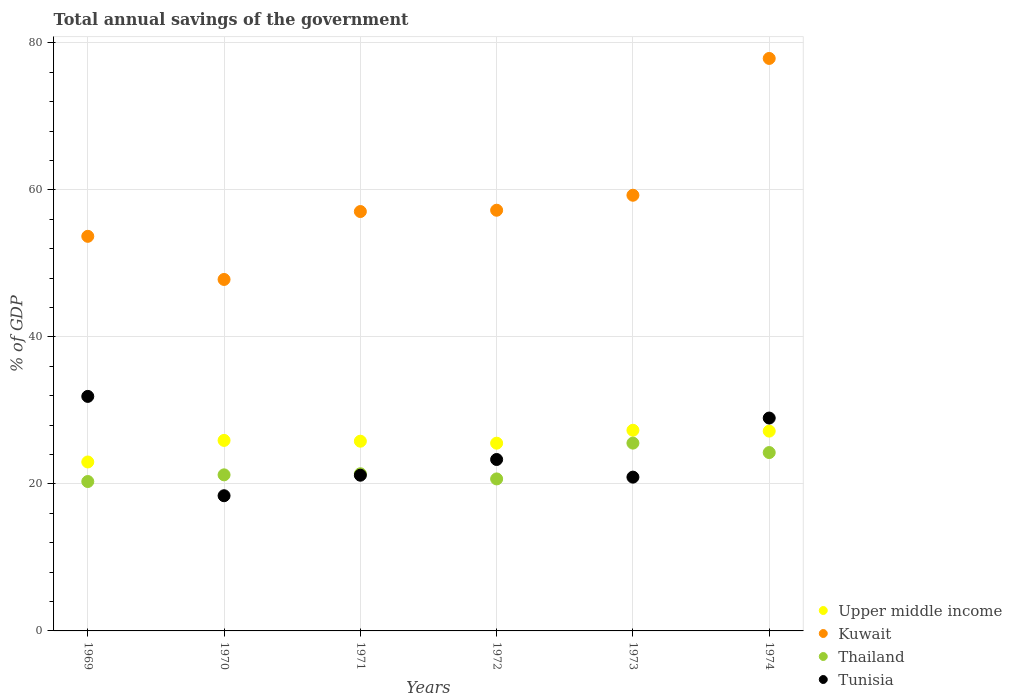Is the number of dotlines equal to the number of legend labels?
Your answer should be very brief. Yes. What is the total annual savings of the government in Kuwait in 1970?
Give a very brief answer. 47.82. Across all years, what is the maximum total annual savings of the government in Tunisia?
Your response must be concise. 31.91. Across all years, what is the minimum total annual savings of the government in Thailand?
Offer a terse response. 20.33. In which year was the total annual savings of the government in Tunisia maximum?
Keep it short and to the point. 1969. In which year was the total annual savings of the government in Kuwait minimum?
Your response must be concise. 1970. What is the total total annual savings of the government in Upper middle income in the graph?
Your response must be concise. 154.76. What is the difference between the total annual savings of the government in Kuwait in 1972 and that in 1973?
Keep it short and to the point. -2.04. What is the difference between the total annual savings of the government in Upper middle income in 1973 and the total annual savings of the government in Thailand in 1972?
Ensure brevity in your answer.  6.62. What is the average total annual savings of the government in Thailand per year?
Your answer should be compact. 22.24. In the year 1971, what is the difference between the total annual savings of the government in Tunisia and total annual savings of the government in Upper middle income?
Provide a short and direct response. -4.63. What is the ratio of the total annual savings of the government in Upper middle income in 1970 to that in 1974?
Your response must be concise. 0.95. Is the total annual savings of the government in Thailand in 1969 less than that in 1970?
Offer a terse response. Yes. What is the difference between the highest and the second highest total annual savings of the government in Upper middle income?
Provide a succinct answer. 0.12. What is the difference between the highest and the lowest total annual savings of the government in Tunisia?
Offer a very short reply. 13.51. In how many years, is the total annual savings of the government in Thailand greater than the average total annual savings of the government in Thailand taken over all years?
Your answer should be compact. 2. Is the sum of the total annual savings of the government in Thailand in 1969 and 1974 greater than the maximum total annual savings of the government in Upper middle income across all years?
Offer a terse response. Yes. Is it the case that in every year, the sum of the total annual savings of the government in Kuwait and total annual savings of the government in Upper middle income  is greater than the total annual savings of the government in Tunisia?
Provide a succinct answer. Yes. Is the total annual savings of the government in Kuwait strictly greater than the total annual savings of the government in Tunisia over the years?
Your answer should be compact. Yes. Is the total annual savings of the government in Thailand strictly less than the total annual savings of the government in Tunisia over the years?
Offer a terse response. No. How many years are there in the graph?
Offer a very short reply. 6. What is the difference between two consecutive major ticks on the Y-axis?
Give a very brief answer. 20. Are the values on the major ticks of Y-axis written in scientific E-notation?
Ensure brevity in your answer.  No. Does the graph contain any zero values?
Provide a succinct answer. No. Where does the legend appear in the graph?
Provide a short and direct response. Bottom right. How many legend labels are there?
Ensure brevity in your answer.  4. What is the title of the graph?
Your answer should be very brief. Total annual savings of the government. Does "Chad" appear as one of the legend labels in the graph?
Provide a short and direct response. No. What is the label or title of the X-axis?
Keep it short and to the point. Years. What is the label or title of the Y-axis?
Your answer should be compact. % of GDP. What is the % of GDP in Upper middle income in 1969?
Offer a terse response. 22.99. What is the % of GDP in Kuwait in 1969?
Make the answer very short. 53.69. What is the % of GDP in Thailand in 1969?
Your response must be concise. 20.33. What is the % of GDP in Tunisia in 1969?
Give a very brief answer. 31.91. What is the % of GDP of Upper middle income in 1970?
Your answer should be compact. 25.92. What is the % of GDP of Kuwait in 1970?
Make the answer very short. 47.82. What is the % of GDP of Thailand in 1970?
Offer a very short reply. 21.24. What is the % of GDP in Tunisia in 1970?
Offer a very short reply. 18.4. What is the % of GDP in Upper middle income in 1971?
Offer a very short reply. 25.81. What is the % of GDP of Kuwait in 1971?
Make the answer very short. 57.06. What is the % of GDP of Thailand in 1971?
Your answer should be very brief. 21.38. What is the % of GDP in Tunisia in 1971?
Provide a short and direct response. 21.19. What is the % of GDP of Upper middle income in 1972?
Offer a terse response. 25.54. What is the % of GDP of Kuwait in 1972?
Give a very brief answer. 57.24. What is the % of GDP of Thailand in 1972?
Make the answer very short. 20.68. What is the % of GDP in Tunisia in 1972?
Your response must be concise. 23.33. What is the % of GDP in Upper middle income in 1973?
Ensure brevity in your answer.  27.3. What is the % of GDP of Kuwait in 1973?
Provide a succinct answer. 59.28. What is the % of GDP in Thailand in 1973?
Your answer should be very brief. 25.55. What is the % of GDP in Tunisia in 1973?
Ensure brevity in your answer.  20.92. What is the % of GDP in Upper middle income in 1974?
Provide a short and direct response. 27.19. What is the % of GDP of Kuwait in 1974?
Give a very brief answer. 77.89. What is the % of GDP of Thailand in 1974?
Provide a succinct answer. 24.27. What is the % of GDP of Tunisia in 1974?
Provide a short and direct response. 28.96. Across all years, what is the maximum % of GDP of Upper middle income?
Provide a short and direct response. 27.3. Across all years, what is the maximum % of GDP in Kuwait?
Your answer should be compact. 77.89. Across all years, what is the maximum % of GDP in Thailand?
Your answer should be compact. 25.55. Across all years, what is the maximum % of GDP in Tunisia?
Ensure brevity in your answer.  31.91. Across all years, what is the minimum % of GDP of Upper middle income?
Provide a succinct answer. 22.99. Across all years, what is the minimum % of GDP in Kuwait?
Give a very brief answer. 47.82. Across all years, what is the minimum % of GDP in Thailand?
Provide a succinct answer. 20.33. Across all years, what is the minimum % of GDP in Tunisia?
Your answer should be very brief. 18.4. What is the total % of GDP of Upper middle income in the graph?
Provide a short and direct response. 154.76. What is the total % of GDP in Kuwait in the graph?
Provide a succinct answer. 352.99. What is the total % of GDP in Thailand in the graph?
Offer a terse response. 133.45. What is the total % of GDP in Tunisia in the graph?
Your answer should be very brief. 144.71. What is the difference between the % of GDP of Upper middle income in 1969 and that in 1970?
Your response must be concise. -2.93. What is the difference between the % of GDP of Kuwait in 1969 and that in 1970?
Your answer should be compact. 5.87. What is the difference between the % of GDP of Thailand in 1969 and that in 1970?
Your answer should be very brief. -0.91. What is the difference between the % of GDP of Tunisia in 1969 and that in 1970?
Ensure brevity in your answer.  13.51. What is the difference between the % of GDP in Upper middle income in 1969 and that in 1971?
Your answer should be very brief. -2.83. What is the difference between the % of GDP in Kuwait in 1969 and that in 1971?
Keep it short and to the point. -3.37. What is the difference between the % of GDP of Thailand in 1969 and that in 1971?
Provide a succinct answer. -1.06. What is the difference between the % of GDP in Tunisia in 1969 and that in 1971?
Ensure brevity in your answer.  10.72. What is the difference between the % of GDP of Upper middle income in 1969 and that in 1972?
Your answer should be very brief. -2.56. What is the difference between the % of GDP of Kuwait in 1969 and that in 1972?
Give a very brief answer. -3.55. What is the difference between the % of GDP of Thailand in 1969 and that in 1972?
Make the answer very short. -0.35. What is the difference between the % of GDP in Tunisia in 1969 and that in 1972?
Make the answer very short. 8.59. What is the difference between the % of GDP in Upper middle income in 1969 and that in 1973?
Your answer should be compact. -4.31. What is the difference between the % of GDP in Kuwait in 1969 and that in 1973?
Keep it short and to the point. -5.59. What is the difference between the % of GDP in Thailand in 1969 and that in 1973?
Offer a very short reply. -5.23. What is the difference between the % of GDP in Tunisia in 1969 and that in 1973?
Give a very brief answer. 10.99. What is the difference between the % of GDP in Upper middle income in 1969 and that in 1974?
Ensure brevity in your answer.  -4.2. What is the difference between the % of GDP in Kuwait in 1969 and that in 1974?
Offer a terse response. -24.2. What is the difference between the % of GDP of Thailand in 1969 and that in 1974?
Offer a terse response. -3.94. What is the difference between the % of GDP in Tunisia in 1969 and that in 1974?
Ensure brevity in your answer.  2.95. What is the difference between the % of GDP in Upper middle income in 1970 and that in 1971?
Provide a succinct answer. 0.11. What is the difference between the % of GDP of Kuwait in 1970 and that in 1971?
Your answer should be compact. -9.24. What is the difference between the % of GDP of Thailand in 1970 and that in 1971?
Give a very brief answer. -0.15. What is the difference between the % of GDP in Tunisia in 1970 and that in 1971?
Keep it short and to the point. -2.79. What is the difference between the % of GDP in Upper middle income in 1970 and that in 1972?
Offer a terse response. 0.38. What is the difference between the % of GDP of Kuwait in 1970 and that in 1972?
Provide a succinct answer. -9.42. What is the difference between the % of GDP of Thailand in 1970 and that in 1972?
Offer a very short reply. 0.55. What is the difference between the % of GDP of Tunisia in 1970 and that in 1972?
Provide a succinct answer. -4.93. What is the difference between the % of GDP in Upper middle income in 1970 and that in 1973?
Your answer should be compact. -1.38. What is the difference between the % of GDP of Kuwait in 1970 and that in 1973?
Ensure brevity in your answer.  -11.46. What is the difference between the % of GDP in Thailand in 1970 and that in 1973?
Offer a terse response. -4.32. What is the difference between the % of GDP in Tunisia in 1970 and that in 1973?
Offer a terse response. -2.53. What is the difference between the % of GDP in Upper middle income in 1970 and that in 1974?
Provide a succinct answer. -1.26. What is the difference between the % of GDP in Kuwait in 1970 and that in 1974?
Offer a terse response. -30.07. What is the difference between the % of GDP in Thailand in 1970 and that in 1974?
Provide a short and direct response. -3.03. What is the difference between the % of GDP of Tunisia in 1970 and that in 1974?
Your answer should be compact. -10.57. What is the difference between the % of GDP in Upper middle income in 1971 and that in 1972?
Offer a very short reply. 0.27. What is the difference between the % of GDP of Kuwait in 1971 and that in 1972?
Give a very brief answer. -0.18. What is the difference between the % of GDP in Thailand in 1971 and that in 1972?
Ensure brevity in your answer.  0.7. What is the difference between the % of GDP of Tunisia in 1971 and that in 1972?
Provide a succinct answer. -2.14. What is the difference between the % of GDP of Upper middle income in 1971 and that in 1973?
Give a very brief answer. -1.49. What is the difference between the % of GDP of Kuwait in 1971 and that in 1973?
Your response must be concise. -2.22. What is the difference between the % of GDP in Thailand in 1971 and that in 1973?
Provide a short and direct response. -4.17. What is the difference between the % of GDP in Tunisia in 1971 and that in 1973?
Provide a short and direct response. 0.26. What is the difference between the % of GDP of Upper middle income in 1971 and that in 1974?
Keep it short and to the point. -1.37. What is the difference between the % of GDP in Kuwait in 1971 and that in 1974?
Provide a short and direct response. -20.83. What is the difference between the % of GDP of Thailand in 1971 and that in 1974?
Your answer should be compact. -2.88. What is the difference between the % of GDP in Tunisia in 1971 and that in 1974?
Ensure brevity in your answer.  -7.78. What is the difference between the % of GDP of Upper middle income in 1972 and that in 1973?
Keep it short and to the point. -1.76. What is the difference between the % of GDP of Kuwait in 1972 and that in 1973?
Offer a terse response. -2.04. What is the difference between the % of GDP of Thailand in 1972 and that in 1973?
Ensure brevity in your answer.  -4.87. What is the difference between the % of GDP of Tunisia in 1972 and that in 1973?
Your answer should be compact. 2.4. What is the difference between the % of GDP in Upper middle income in 1972 and that in 1974?
Give a very brief answer. -1.64. What is the difference between the % of GDP in Kuwait in 1972 and that in 1974?
Your answer should be very brief. -20.65. What is the difference between the % of GDP in Thailand in 1972 and that in 1974?
Keep it short and to the point. -3.59. What is the difference between the % of GDP of Tunisia in 1972 and that in 1974?
Make the answer very short. -5.64. What is the difference between the % of GDP in Upper middle income in 1973 and that in 1974?
Provide a succinct answer. 0.12. What is the difference between the % of GDP of Kuwait in 1973 and that in 1974?
Make the answer very short. -18.61. What is the difference between the % of GDP in Thailand in 1973 and that in 1974?
Provide a short and direct response. 1.28. What is the difference between the % of GDP in Tunisia in 1973 and that in 1974?
Give a very brief answer. -8.04. What is the difference between the % of GDP of Upper middle income in 1969 and the % of GDP of Kuwait in 1970?
Provide a short and direct response. -24.83. What is the difference between the % of GDP of Upper middle income in 1969 and the % of GDP of Thailand in 1970?
Offer a very short reply. 1.75. What is the difference between the % of GDP of Upper middle income in 1969 and the % of GDP of Tunisia in 1970?
Ensure brevity in your answer.  4.59. What is the difference between the % of GDP of Kuwait in 1969 and the % of GDP of Thailand in 1970?
Provide a short and direct response. 32.45. What is the difference between the % of GDP in Kuwait in 1969 and the % of GDP in Tunisia in 1970?
Keep it short and to the point. 35.29. What is the difference between the % of GDP in Thailand in 1969 and the % of GDP in Tunisia in 1970?
Provide a short and direct response. 1.93. What is the difference between the % of GDP in Upper middle income in 1969 and the % of GDP in Kuwait in 1971?
Your answer should be compact. -34.08. What is the difference between the % of GDP in Upper middle income in 1969 and the % of GDP in Thailand in 1971?
Offer a terse response. 1.6. What is the difference between the % of GDP of Upper middle income in 1969 and the % of GDP of Tunisia in 1971?
Your answer should be compact. 1.8. What is the difference between the % of GDP in Kuwait in 1969 and the % of GDP in Thailand in 1971?
Give a very brief answer. 32.31. What is the difference between the % of GDP in Kuwait in 1969 and the % of GDP in Tunisia in 1971?
Your answer should be compact. 32.5. What is the difference between the % of GDP of Thailand in 1969 and the % of GDP of Tunisia in 1971?
Provide a succinct answer. -0.86. What is the difference between the % of GDP of Upper middle income in 1969 and the % of GDP of Kuwait in 1972?
Provide a short and direct response. -34.25. What is the difference between the % of GDP of Upper middle income in 1969 and the % of GDP of Thailand in 1972?
Provide a succinct answer. 2.31. What is the difference between the % of GDP in Upper middle income in 1969 and the % of GDP in Tunisia in 1972?
Provide a succinct answer. -0.34. What is the difference between the % of GDP of Kuwait in 1969 and the % of GDP of Thailand in 1972?
Offer a terse response. 33.01. What is the difference between the % of GDP of Kuwait in 1969 and the % of GDP of Tunisia in 1972?
Offer a terse response. 30.37. What is the difference between the % of GDP in Thailand in 1969 and the % of GDP in Tunisia in 1972?
Keep it short and to the point. -3. What is the difference between the % of GDP in Upper middle income in 1969 and the % of GDP in Kuwait in 1973?
Make the answer very short. -36.29. What is the difference between the % of GDP in Upper middle income in 1969 and the % of GDP in Thailand in 1973?
Keep it short and to the point. -2.56. What is the difference between the % of GDP in Upper middle income in 1969 and the % of GDP in Tunisia in 1973?
Ensure brevity in your answer.  2.06. What is the difference between the % of GDP in Kuwait in 1969 and the % of GDP in Thailand in 1973?
Provide a short and direct response. 28.14. What is the difference between the % of GDP in Kuwait in 1969 and the % of GDP in Tunisia in 1973?
Ensure brevity in your answer.  32.77. What is the difference between the % of GDP of Thailand in 1969 and the % of GDP of Tunisia in 1973?
Offer a very short reply. -0.6. What is the difference between the % of GDP of Upper middle income in 1969 and the % of GDP of Kuwait in 1974?
Your answer should be compact. -54.91. What is the difference between the % of GDP in Upper middle income in 1969 and the % of GDP in Thailand in 1974?
Offer a terse response. -1.28. What is the difference between the % of GDP in Upper middle income in 1969 and the % of GDP in Tunisia in 1974?
Offer a terse response. -5.98. What is the difference between the % of GDP in Kuwait in 1969 and the % of GDP in Thailand in 1974?
Offer a terse response. 29.42. What is the difference between the % of GDP in Kuwait in 1969 and the % of GDP in Tunisia in 1974?
Offer a terse response. 24.73. What is the difference between the % of GDP in Thailand in 1969 and the % of GDP in Tunisia in 1974?
Your answer should be very brief. -8.64. What is the difference between the % of GDP of Upper middle income in 1970 and the % of GDP of Kuwait in 1971?
Your response must be concise. -31.14. What is the difference between the % of GDP of Upper middle income in 1970 and the % of GDP of Thailand in 1971?
Ensure brevity in your answer.  4.54. What is the difference between the % of GDP in Upper middle income in 1970 and the % of GDP in Tunisia in 1971?
Provide a succinct answer. 4.73. What is the difference between the % of GDP in Kuwait in 1970 and the % of GDP in Thailand in 1971?
Provide a short and direct response. 26.44. What is the difference between the % of GDP of Kuwait in 1970 and the % of GDP of Tunisia in 1971?
Your answer should be compact. 26.64. What is the difference between the % of GDP of Thailand in 1970 and the % of GDP of Tunisia in 1971?
Offer a very short reply. 0.05. What is the difference between the % of GDP of Upper middle income in 1970 and the % of GDP of Kuwait in 1972?
Provide a short and direct response. -31.32. What is the difference between the % of GDP in Upper middle income in 1970 and the % of GDP in Thailand in 1972?
Ensure brevity in your answer.  5.24. What is the difference between the % of GDP of Upper middle income in 1970 and the % of GDP of Tunisia in 1972?
Offer a very short reply. 2.6. What is the difference between the % of GDP in Kuwait in 1970 and the % of GDP in Thailand in 1972?
Ensure brevity in your answer.  27.14. What is the difference between the % of GDP of Kuwait in 1970 and the % of GDP of Tunisia in 1972?
Your answer should be compact. 24.5. What is the difference between the % of GDP of Thailand in 1970 and the % of GDP of Tunisia in 1972?
Ensure brevity in your answer.  -2.09. What is the difference between the % of GDP of Upper middle income in 1970 and the % of GDP of Kuwait in 1973?
Provide a short and direct response. -33.36. What is the difference between the % of GDP of Upper middle income in 1970 and the % of GDP of Thailand in 1973?
Your answer should be compact. 0.37. What is the difference between the % of GDP of Upper middle income in 1970 and the % of GDP of Tunisia in 1973?
Offer a terse response. 5. What is the difference between the % of GDP of Kuwait in 1970 and the % of GDP of Thailand in 1973?
Give a very brief answer. 22.27. What is the difference between the % of GDP in Kuwait in 1970 and the % of GDP in Tunisia in 1973?
Provide a short and direct response. 26.9. What is the difference between the % of GDP in Thailand in 1970 and the % of GDP in Tunisia in 1973?
Ensure brevity in your answer.  0.31. What is the difference between the % of GDP of Upper middle income in 1970 and the % of GDP of Kuwait in 1974?
Offer a terse response. -51.97. What is the difference between the % of GDP of Upper middle income in 1970 and the % of GDP of Thailand in 1974?
Ensure brevity in your answer.  1.65. What is the difference between the % of GDP of Upper middle income in 1970 and the % of GDP of Tunisia in 1974?
Your answer should be very brief. -3.04. What is the difference between the % of GDP in Kuwait in 1970 and the % of GDP in Thailand in 1974?
Your answer should be very brief. 23.55. What is the difference between the % of GDP of Kuwait in 1970 and the % of GDP of Tunisia in 1974?
Your answer should be very brief. 18.86. What is the difference between the % of GDP of Thailand in 1970 and the % of GDP of Tunisia in 1974?
Keep it short and to the point. -7.73. What is the difference between the % of GDP in Upper middle income in 1971 and the % of GDP in Kuwait in 1972?
Your answer should be compact. -31.43. What is the difference between the % of GDP of Upper middle income in 1971 and the % of GDP of Thailand in 1972?
Offer a very short reply. 5.13. What is the difference between the % of GDP of Upper middle income in 1971 and the % of GDP of Tunisia in 1972?
Provide a succinct answer. 2.49. What is the difference between the % of GDP of Kuwait in 1971 and the % of GDP of Thailand in 1972?
Ensure brevity in your answer.  36.38. What is the difference between the % of GDP of Kuwait in 1971 and the % of GDP of Tunisia in 1972?
Provide a short and direct response. 33.74. What is the difference between the % of GDP in Thailand in 1971 and the % of GDP in Tunisia in 1972?
Offer a very short reply. -1.94. What is the difference between the % of GDP in Upper middle income in 1971 and the % of GDP in Kuwait in 1973?
Your response must be concise. -33.47. What is the difference between the % of GDP in Upper middle income in 1971 and the % of GDP in Thailand in 1973?
Keep it short and to the point. 0.26. What is the difference between the % of GDP in Upper middle income in 1971 and the % of GDP in Tunisia in 1973?
Provide a short and direct response. 4.89. What is the difference between the % of GDP in Kuwait in 1971 and the % of GDP in Thailand in 1973?
Provide a short and direct response. 31.51. What is the difference between the % of GDP in Kuwait in 1971 and the % of GDP in Tunisia in 1973?
Provide a short and direct response. 36.14. What is the difference between the % of GDP of Thailand in 1971 and the % of GDP of Tunisia in 1973?
Your answer should be very brief. 0.46. What is the difference between the % of GDP in Upper middle income in 1971 and the % of GDP in Kuwait in 1974?
Provide a short and direct response. -52.08. What is the difference between the % of GDP of Upper middle income in 1971 and the % of GDP of Thailand in 1974?
Provide a succinct answer. 1.55. What is the difference between the % of GDP in Upper middle income in 1971 and the % of GDP in Tunisia in 1974?
Offer a terse response. -3.15. What is the difference between the % of GDP of Kuwait in 1971 and the % of GDP of Thailand in 1974?
Your answer should be compact. 32.79. What is the difference between the % of GDP of Kuwait in 1971 and the % of GDP of Tunisia in 1974?
Provide a short and direct response. 28.1. What is the difference between the % of GDP in Thailand in 1971 and the % of GDP in Tunisia in 1974?
Provide a succinct answer. -7.58. What is the difference between the % of GDP of Upper middle income in 1972 and the % of GDP of Kuwait in 1973?
Give a very brief answer. -33.73. What is the difference between the % of GDP in Upper middle income in 1972 and the % of GDP in Thailand in 1973?
Provide a short and direct response. -0.01. What is the difference between the % of GDP of Upper middle income in 1972 and the % of GDP of Tunisia in 1973?
Ensure brevity in your answer.  4.62. What is the difference between the % of GDP in Kuwait in 1972 and the % of GDP in Thailand in 1973?
Give a very brief answer. 31.69. What is the difference between the % of GDP in Kuwait in 1972 and the % of GDP in Tunisia in 1973?
Provide a succinct answer. 36.32. What is the difference between the % of GDP of Thailand in 1972 and the % of GDP of Tunisia in 1973?
Give a very brief answer. -0.24. What is the difference between the % of GDP of Upper middle income in 1972 and the % of GDP of Kuwait in 1974?
Your answer should be very brief. -52.35. What is the difference between the % of GDP of Upper middle income in 1972 and the % of GDP of Thailand in 1974?
Make the answer very short. 1.28. What is the difference between the % of GDP of Upper middle income in 1972 and the % of GDP of Tunisia in 1974?
Your answer should be very brief. -3.42. What is the difference between the % of GDP of Kuwait in 1972 and the % of GDP of Thailand in 1974?
Your answer should be compact. 32.97. What is the difference between the % of GDP of Kuwait in 1972 and the % of GDP of Tunisia in 1974?
Offer a very short reply. 28.28. What is the difference between the % of GDP in Thailand in 1972 and the % of GDP in Tunisia in 1974?
Your answer should be very brief. -8.28. What is the difference between the % of GDP of Upper middle income in 1973 and the % of GDP of Kuwait in 1974?
Keep it short and to the point. -50.59. What is the difference between the % of GDP of Upper middle income in 1973 and the % of GDP of Thailand in 1974?
Give a very brief answer. 3.03. What is the difference between the % of GDP in Upper middle income in 1973 and the % of GDP in Tunisia in 1974?
Provide a succinct answer. -1.66. What is the difference between the % of GDP in Kuwait in 1973 and the % of GDP in Thailand in 1974?
Ensure brevity in your answer.  35.01. What is the difference between the % of GDP in Kuwait in 1973 and the % of GDP in Tunisia in 1974?
Keep it short and to the point. 30.32. What is the difference between the % of GDP in Thailand in 1973 and the % of GDP in Tunisia in 1974?
Offer a very short reply. -3.41. What is the average % of GDP of Upper middle income per year?
Ensure brevity in your answer.  25.79. What is the average % of GDP of Kuwait per year?
Keep it short and to the point. 58.83. What is the average % of GDP of Thailand per year?
Offer a terse response. 22.24. What is the average % of GDP in Tunisia per year?
Provide a short and direct response. 24.12. In the year 1969, what is the difference between the % of GDP of Upper middle income and % of GDP of Kuwait?
Offer a terse response. -30.7. In the year 1969, what is the difference between the % of GDP of Upper middle income and % of GDP of Thailand?
Offer a very short reply. 2.66. In the year 1969, what is the difference between the % of GDP in Upper middle income and % of GDP in Tunisia?
Provide a succinct answer. -8.92. In the year 1969, what is the difference between the % of GDP of Kuwait and % of GDP of Thailand?
Make the answer very short. 33.36. In the year 1969, what is the difference between the % of GDP in Kuwait and % of GDP in Tunisia?
Keep it short and to the point. 21.78. In the year 1969, what is the difference between the % of GDP of Thailand and % of GDP of Tunisia?
Your response must be concise. -11.58. In the year 1970, what is the difference between the % of GDP of Upper middle income and % of GDP of Kuwait?
Make the answer very short. -21.9. In the year 1970, what is the difference between the % of GDP of Upper middle income and % of GDP of Thailand?
Give a very brief answer. 4.69. In the year 1970, what is the difference between the % of GDP in Upper middle income and % of GDP in Tunisia?
Your response must be concise. 7.53. In the year 1970, what is the difference between the % of GDP of Kuwait and % of GDP of Thailand?
Provide a short and direct response. 26.59. In the year 1970, what is the difference between the % of GDP in Kuwait and % of GDP in Tunisia?
Ensure brevity in your answer.  29.43. In the year 1970, what is the difference between the % of GDP of Thailand and % of GDP of Tunisia?
Your answer should be very brief. 2.84. In the year 1971, what is the difference between the % of GDP in Upper middle income and % of GDP in Kuwait?
Your answer should be very brief. -31.25. In the year 1971, what is the difference between the % of GDP of Upper middle income and % of GDP of Thailand?
Your response must be concise. 4.43. In the year 1971, what is the difference between the % of GDP in Upper middle income and % of GDP in Tunisia?
Offer a very short reply. 4.63. In the year 1971, what is the difference between the % of GDP in Kuwait and % of GDP in Thailand?
Keep it short and to the point. 35.68. In the year 1971, what is the difference between the % of GDP of Kuwait and % of GDP of Tunisia?
Your answer should be compact. 35.88. In the year 1971, what is the difference between the % of GDP in Thailand and % of GDP in Tunisia?
Offer a terse response. 0.2. In the year 1972, what is the difference between the % of GDP in Upper middle income and % of GDP in Kuwait?
Ensure brevity in your answer.  -31.7. In the year 1972, what is the difference between the % of GDP of Upper middle income and % of GDP of Thailand?
Ensure brevity in your answer.  4.86. In the year 1972, what is the difference between the % of GDP of Upper middle income and % of GDP of Tunisia?
Your answer should be compact. 2.22. In the year 1972, what is the difference between the % of GDP in Kuwait and % of GDP in Thailand?
Give a very brief answer. 36.56. In the year 1972, what is the difference between the % of GDP in Kuwait and % of GDP in Tunisia?
Provide a short and direct response. 33.91. In the year 1972, what is the difference between the % of GDP of Thailand and % of GDP of Tunisia?
Offer a very short reply. -2.64. In the year 1973, what is the difference between the % of GDP in Upper middle income and % of GDP in Kuwait?
Provide a succinct answer. -31.98. In the year 1973, what is the difference between the % of GDP in Upper middle income and % of GDP in Thailand?
Ensure brevity in your answer.  1.75. In the year 1973, what is the difference between the % of GDP in Upper middle income and % of GDP in Tunisia?
Give a very brief answer. 6.38. In the year 1973, what is the difference between the % of GDP in Kuwait and % of GDP in Thailand?
Provide a succinct answer. 33.73. In the year 1973, what is the difference between the % of GDP of Kuwait and % of GDP of Tunisia?
Make the answer very short. 38.36. In the year 1973, what is the difference between the % of GDP in Thailand and % of GDP in Tunisia?
Your answer should be compact. 4.63. In the year 1974, what is the difference between the % of GDP of Upper middle income and % of GDP of Kuwait?
Provide a succinct answer. -50.71. In the year 1974, what is the difference between the % of GDP in Upper middle income and % of GDP in Thailand?
Your response must be concise. 2.92. In the year 1974, what is the difference between the % of GDP in Upper middle income and % of GDP in Tunisia?
Provide a short and direct response. -1.78. In the year 1974, what is the difference between the % of GDP in Kuwait and % of GDP in Thailand?
Your answer should be compact. 53.63. In the year 1974, what is the difference between the % of GDP of Kuwait and % of GDP of Tunisia?
Offer a terse response. 48.93. In the year 1974, what is the difference between the % of GDP of Thailand and % of GDP of Tunisia?
Provide a short and direct response. -4.7. What is the ratio of the % of GDP of Upper middle income in 1969 to that in 1970?
Your answer should be very brief. 0.89. What is the ratio of the % of GDP of Kuwait in 1969 to that in 1970?
Provide a succinct answer. 1.12. What is the ratio of the % of GDP in Thailand in 1969 to that in 1970?
Offer a terse response. 0.96. What is the ratio of the % of GDP of Tunisia in 1969 to that in 1970?
Give a very brief answer. 1.73. What is the ratio of the % of GDP of Upper middle income in 1969 to that in 1971?
Provide a succinct answer. 0.89. What is the ratio of the % of GDP of Kuwait in 1969 to that in 1971?
Your response must be concise. 0.94. What is the ratio of the % of GDP in Thailand in 1969 to that in 1971?
Make the answer very short. 0.95. What is the ratio of the % of GDP in Tunisia in 1969 to that in 1971?
Your answer should be compact. 1.51. What is the ratio of the % of GDP in Upper middle income in 1969 to that in 1972?
Provide a short and direct response. 0.9. What is the ratio of the % of GDP in Kuwait in 1969 to that in 1972?
Ensure brevity in your answer.  0.94. What is the ratio of the % of GDP of Thailand in 1969 to that in 1972?
Your answer should be compact. 0.98. What is the ratio of the % of GDP of Tunisia in 1969 to that in 1972?
Your answer should be very brief. 1.37. What is the ratio of the % of GDP in Upper middle income in 1969 to that in 1973?
Provide a succinct answer. 0.84. What is the ratio of the % of GDP of Kuwait in 1969 to that in 1973?
Provide a short and direct response. 0.91. What is the ratio of the % of GDP of Thailand in 1969 to that in 1973?
Ensure brevity in your answer.  0.8. What is the ratio of the % of GDP of Tunisia in 1969 to that in 1973?
Provide a short and direct response. 1.53. What is the ratio of the % of GDP of Upper middle income in 1969 to that in 1974?
Your response must be concise. 0.85. What is the ratio of the % of GDP in Kuwait in 1969 to that in 1974?
Your answer should be compact. 0.69. What is the ratio of the % of GDP of Thailand in 1969 to that in 1974?
Give a very brief answer. 0.84. What is the ratio of the % of GDP in Tunisia in 1969 to that in 1974?
Keep it short and to the point. 1.1. What is the ratio of the % of GDP in Kuwait in 1970 to that in 1971?
Your response must be concise. 0.84. What is the ratio of the % of GDP in Thailand in 1970 to that in 1971?
Offer a terse response. 0.99. What is the ratio of the % of GDP of Tunisia in 1970 to that in 1971?
Offer a very short reply. 0.87. What is the ratio of the % of GDP in Upper middle income in 1970 to that in 1972?
Your response must be concise. 1.01. What is the ratio of the % of GDP of Kuwait in 1970 to that in 1972?
Offer a terse response. 0.84. What is the ratio of the % of GDP in Thailand in 1970 to that in 1972?
Provide a succinct answer. 1.03. What is the ratio of the % of GDP in Tunisia in 1970 to that in 1972?
Provide a short and direct response. 0.79. What is the ratio of the % of GDP in Upper middle income in 1970 to that in 1973?
Provide a succinct answer. 0.95. What is the ratio of the % of GDP in Kuwait in 1970 to that in 1973?
Offer a very short reply. 0.81. What is the ratio of the % of GDP of Thailand in 1970 to that in 1973?
Your answer should be compact. 0.83. What is the ratio of the % of GDP of Tunisia in 1970 to that in 1973?
Offer a very short reply. 0.88. What is the ratio of the % of GDP of Upper middle income in 1970 to that in 1974?
Keep it short and to the point. 0.95. What is the ratio of the % of GDP of Kuwait in 1970 to that in 1974?
Keep it short and to the point. 0.61. What is the ratio of the % of GDP in Thailand in 1970 to that in 1974?
Give a very brief answer. 0.88. What is the ratio of the % of GDP of Tunisia in 1970 to that in 1974?
Your answer should be very brief. 0.64. What is the ratio of the % of GDP of Upper middle income in 1971 to that in 1972?
Provide a short and direct response. 1.01. What is the ratio of the % of GDP in Kuwait in 1971 to that in 1972?
Make the answer very short. 1. What is the ratio of the % of GDP of Thailand in 1971 to that in 1972?
Give a very brief answer. 1.03. What is the ratio of the % of GDP of Tunisia in 1971 to that in 1972?
Give a very brief answer. 0.91. What is the ratio of the % of GDP in Upper middle income in 1971 to that in 1973?
Provide a succinct answer. 0.95. What is the ratio of the % of GDP in Kuwait in 1971 to that in 1973?
Your answer should be compact. 0.96. What is the ratio of the % of GDP in Thailand in 1971 to that in 1973?
Provide a succinct answer. 0.84. What is the ratio of the % of GDP of Tunisia in 1971 to that in 1973?
Provide a short and direct response. 1.01. What is the ratio of the % of GDP of Upper middle income in 1971 to that in 1974?
Offer a very short reply. 0.95. What is the ratio of the % of GDP in Kuwait in 1971 to that in 1974?
Keep it short and to the point. 0.73. What is the ratio of the % of GDP in Thailand in 1971 to that in 1974?
Provide a short and direct response. 0.88. What is the ratio of the % of GDP of Tunisia in 1971 to that in 1974?
Give a very brief answer. 0.73. What is the ratio of the % of GDP in Upper middle income in 1972 to that in 1973?
Offer a very short reply. 0.94. What is the ratio of the % of GDP in Kuwait in 1972 to that in 1973?
Give a very brief answer. 0.97. What is the ratio of the % of GDP of Thailand in 1972 to that in 1973?
Ensure brevity in your answer.  0.81. What is the ratio of the % of GDP in Tunisia in 1972 to that in 1973?
Ensure brevity in your answer.  1.11. What is the ratio of the % of GDP in Upper middle income in 1972 to that in 1974?
Your answer should be compact. 0.94. What is the ratio of the % of GDP in Kuwait in 1972 to that in 1974?
Ensure brevity in your answer.  0.73. What is the ratio of the % of GDP of Thailand in 1972 to that in 1974?
Keep it short and to the point. 0.85. What is the ratio of the % of GDP of Tunisia in 1972 to that in 1974?
Provide a succinct answer. 0.81. What is the ratio of the % of GDP of Upper middle income in 1973 to that in 1974?
Keep it short and to the point. 1. What is the ratio of the % of GDP in Kuwait in 1973 to that in 1974?
Your answer should be compact. 0.76. What is the ratio of the % of GDP in Thailand in 1973 to that in 1974?
Give a very brief answer. 1.05. What is the ratio of the % of GDP in Tunisia in 1973 to that in 1974?
Offer a very short reply. 0.72. What is the difference between the highest and the second highest % of GDP in Upper middle income?
Keep it short and to the point. 0.12. What is the difference between the highest and the second highest % of GDP in Kuwait?
Your answer should be very brief. 18.61. What is the difference between the highest and the second highest % of GDP of Thailand?
Offer a very short reply. 1.28. What is the difference between the highest and the second highest % of GDP in Tunisia?
Your response must be concise. 2.95. What is the difference between the highest and the lowest % of GDP in Upper middle income?
Make the answer very short. 4.31. What is the difference between the highest and the lowest % of GDP of Kuwait?
Ensure brevity in your answer.  30.07. What is the difference between the highest and the lowest % of GDP of Thailand?
Your answer should be very brief. 5.23. What is the difference between the highest and the lowest % of GDP in Tunisia?
Offer a terse response. 13.51. 